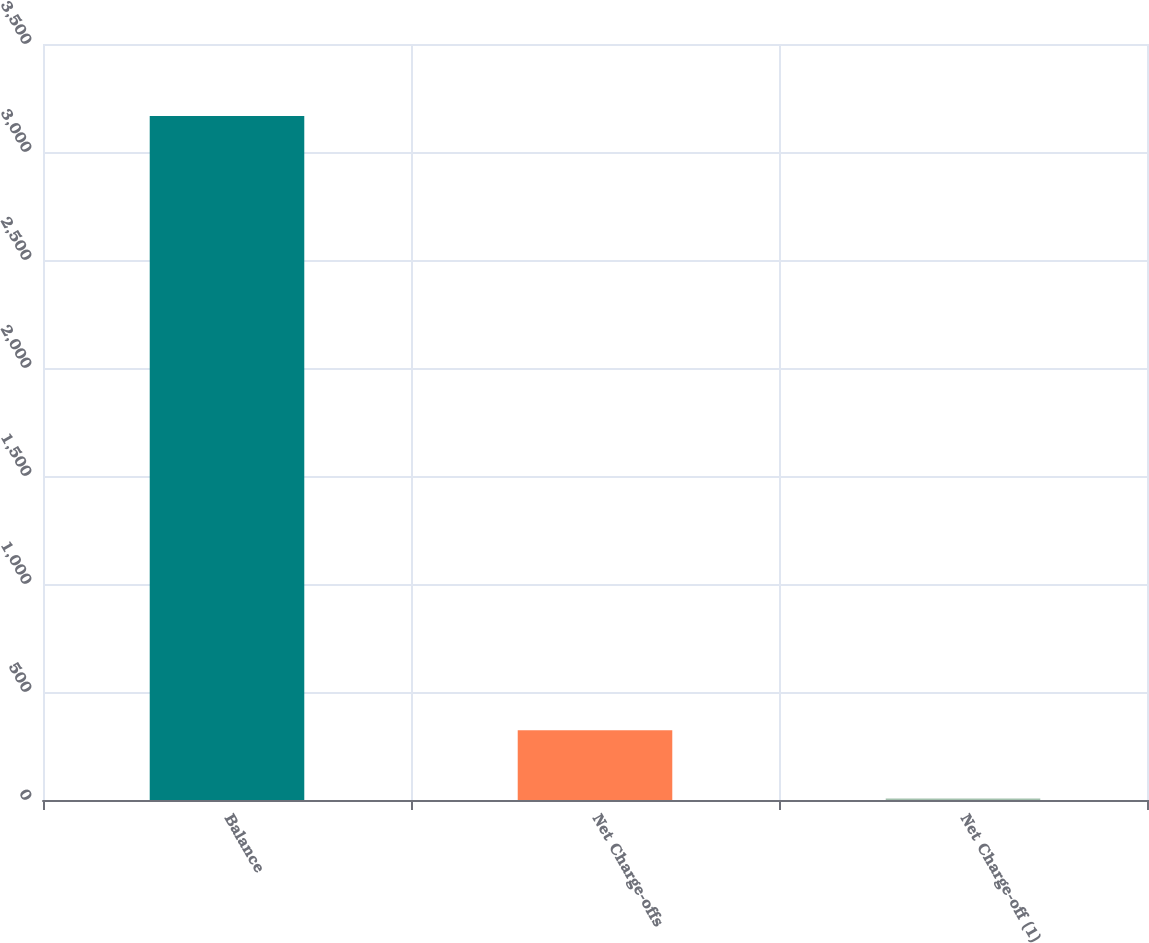Convert chart. <chart><loc_0><loc_0><loc_500><loc_500><bar_chart><fcel>Balance<fcel>Net Charge-offs<fcel>Net Charge-off (1)<nl><fcel>3167<fcel>323.11<fcel>7.12<nl></chart> 